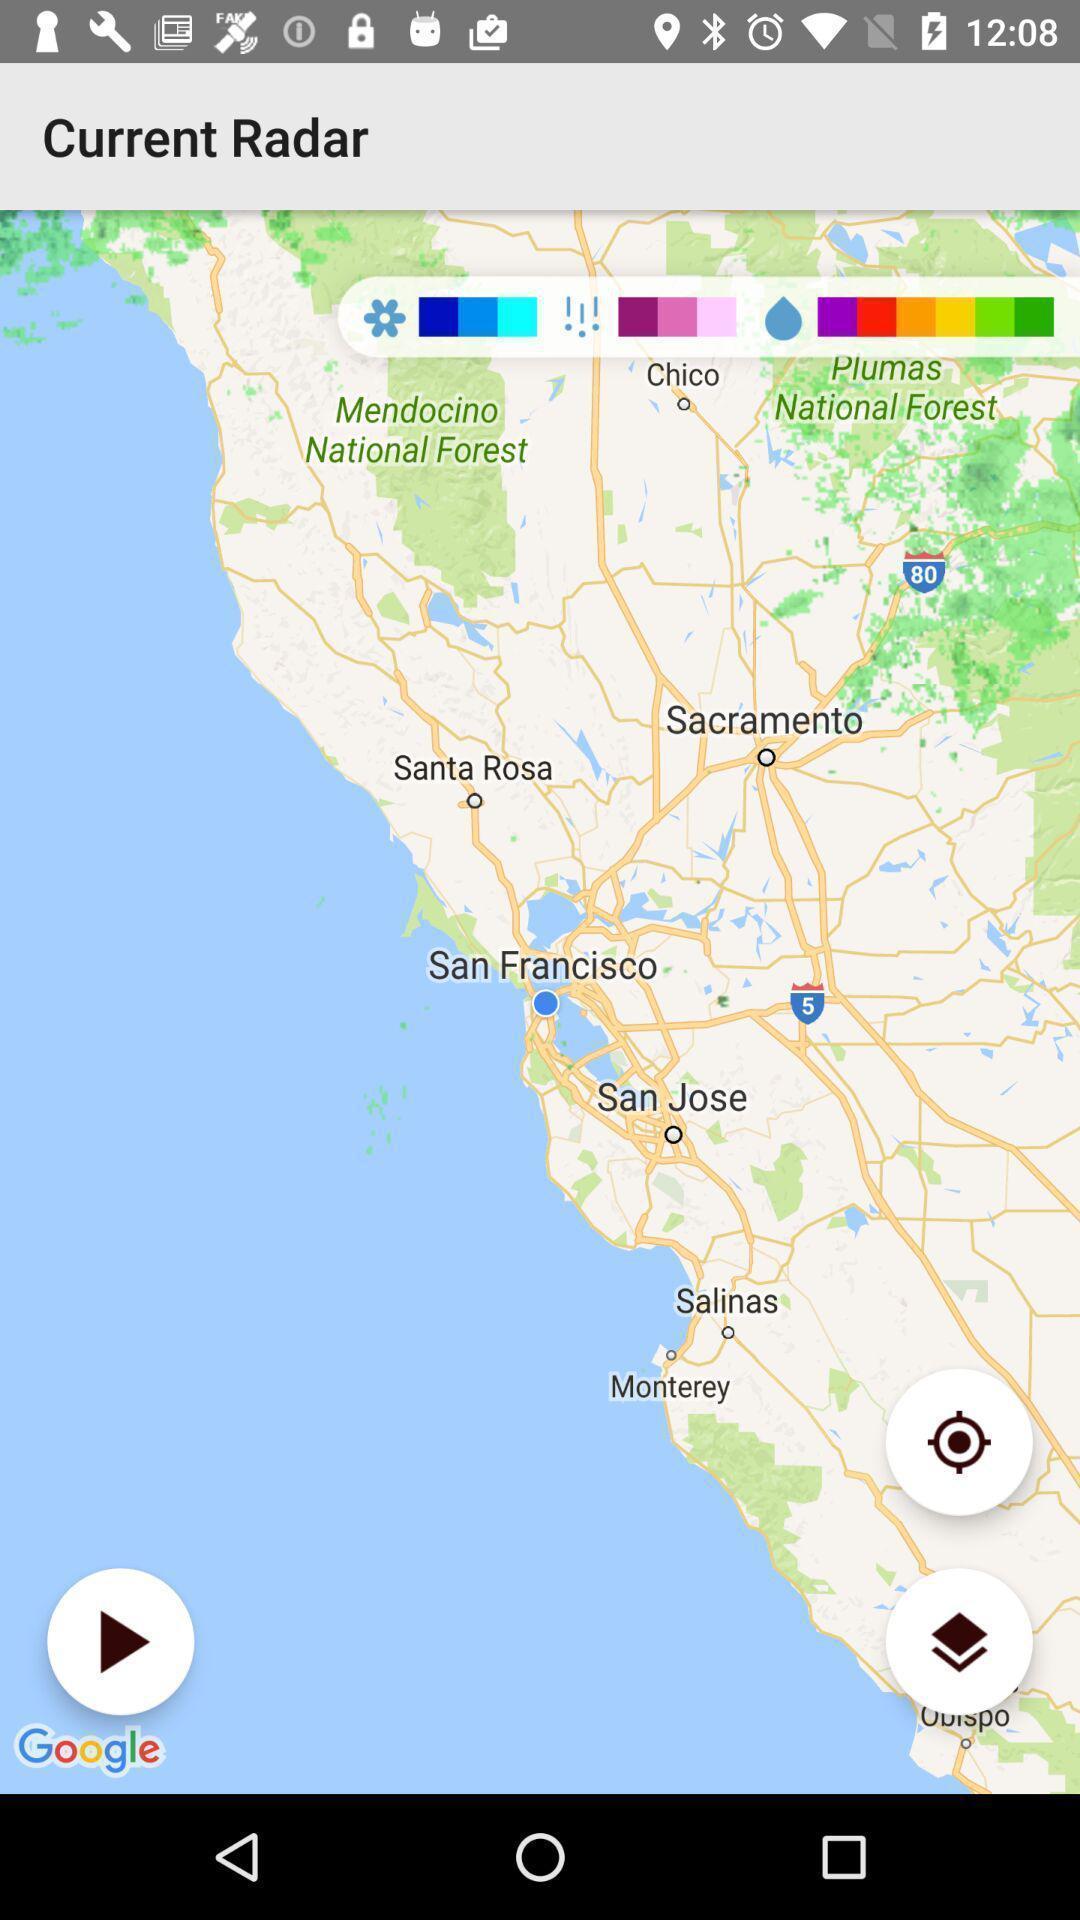Provide a description of this screenshot. Page that displaying gps application. 